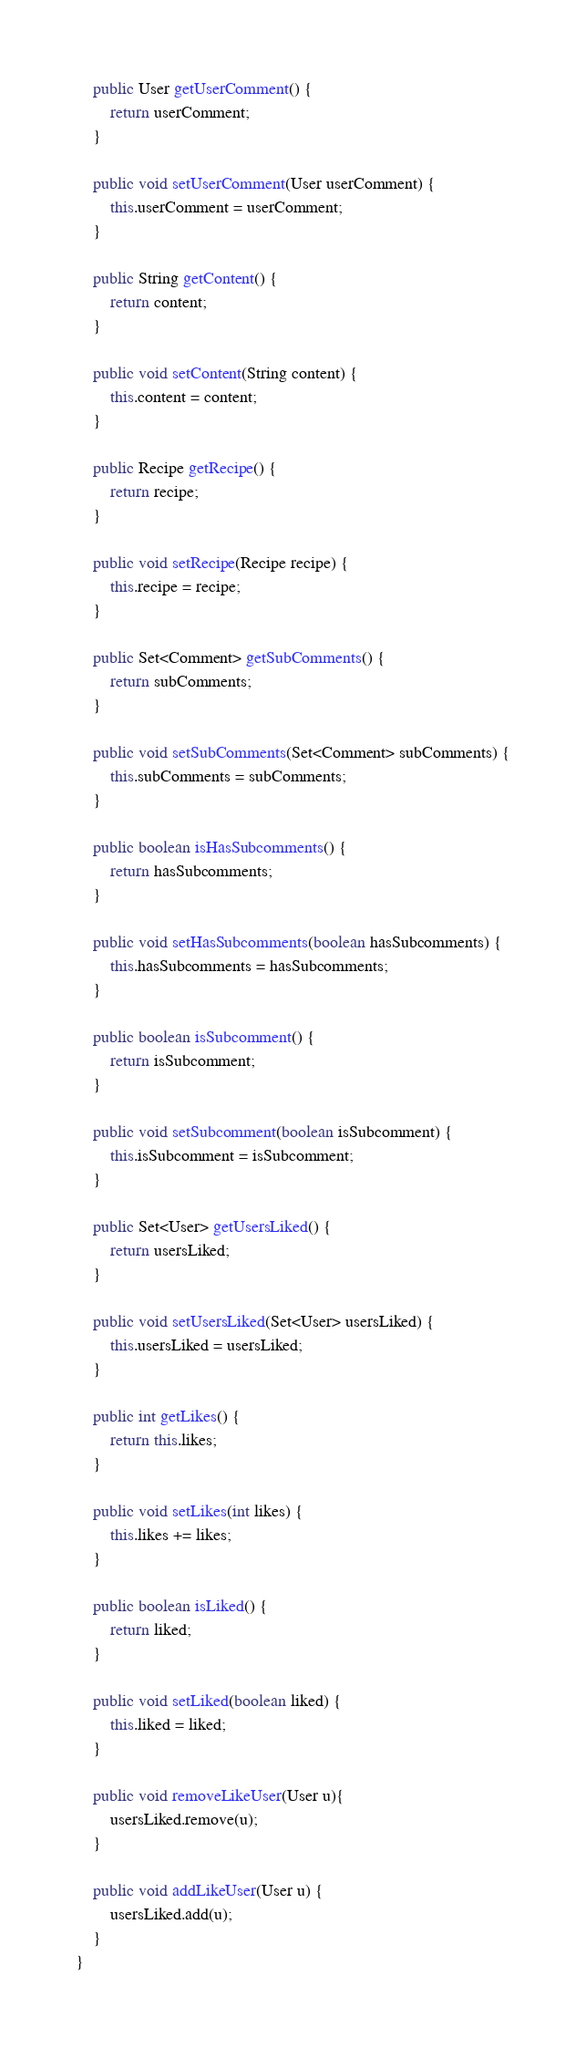Convert code to text. <code><loc_0><loc_0><loc_500><loc_500><_Java_>
    public User getUserComment() {
        return userComment;
    }

    public void setUserComment(User userComment) {
        this.userComment = userComment;
    }

    public String getContent() {
        return content;
    }

    public void setContent(String content) {
        this.content = content;
    }

    public Recipe getRecipe() {
        return recipe;
    }

    public void setRecipe(Recipe recipe) {
        this.recipe = recipe;
    }

    public Set<Comment> getSubComments() {
        return subComments;
    }

    public void setSubComments(Set<Comment> subComments) {
        this.subComments = subComments;
    }

    public boolean isHasSubcomments() {
        return hasSubcomments;
    }

    public void setHasSubcomments(boolean hasSubcomments) {
        this.hasSubcomments = hasSubcomments;
    }

    public boolean isSubcomment() {
        return isSubcomment;
    }

    public void setSubcomment(boolean isSubcomment) {
        this.isSubcomment = isSubcomment;
    }

    public Set<User> getUsersLiked() {
        return usersLiked;
    }

    public void setUsersLiked(Set<User> usersLiked) {
        this.usersLiked = usersLiked;
    }

    public int getLikes() {
        return this.likes;
    }

    public void setLikes(int likes) {
        this.likes += likes;
    }

    public boolean isLiked() {
        return liked;
    }

    public void setLiked(boolean liked) {
        this.liked = liked;
    }
    
    public void removeLikeUser(User u){
        usersLiked.remove(u);
    }

	public void addLikeUser(User u) {
        usersLiked.add(u);
	}
}</code> 